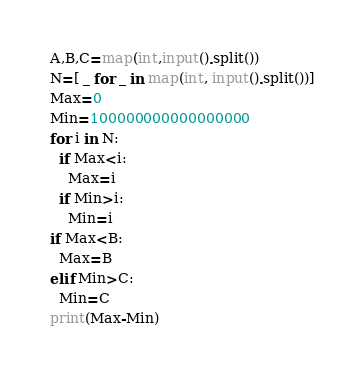<code> <loc_0><loc_0><loc_500><loc_500><_Python_>A,B,C=map(int,input().split())
N=[ _ for _ in map(int, input().split())]
Max=0
Min=100000000000000000
for i in N:
  if Max<i:
    Max=i
  if Min>i:
    Min=i
if Max<B:
  Max=B
elif Min>C:
  Min=C
print(Max-Min)</code> 